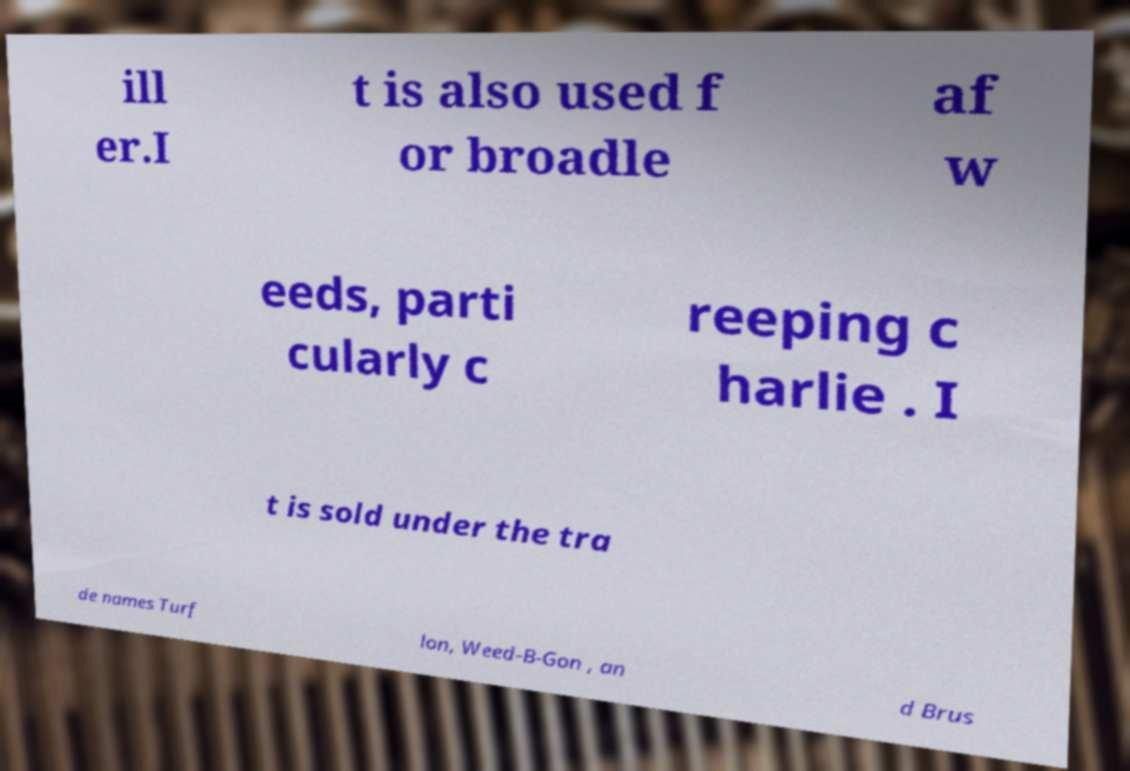I need the written content from this picture converted into text. Can you do that? ill er.I t is also used f or broadle af w eeds, parti cularly c reeping c harlie . I t is sold under the tra de names Turf lon, Weed-B-Gon , an d Brus 